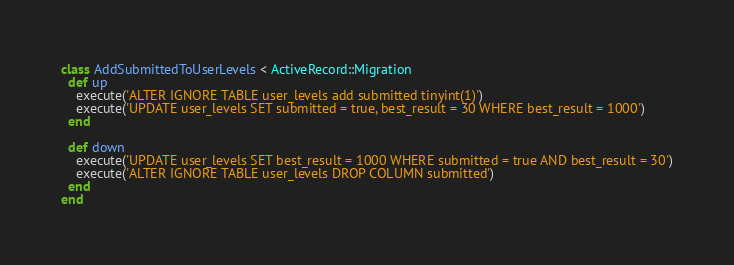Convert code to text. <code><loc_0><loc_0><loc_500><loc_500><_Ruby_>class AddSubmittedToUserLevels < ActiveRecord::Migration
  def up
    execute('ALTER IGNORE TABLE user_levels add submitted tinyint(1)')
    execute('UPDATE user_levels SET submitted = true, best_result = 30 WHERE best_result = 1000')
  end

  def down
    execute('UPDATE user_levels SET best_result = 1000 WHERE submitted = true AND best_result = 30')
    execute('ALTER IGNORE TABLE user_levels DROP COLUMN submitted')
  end
end
</code> 